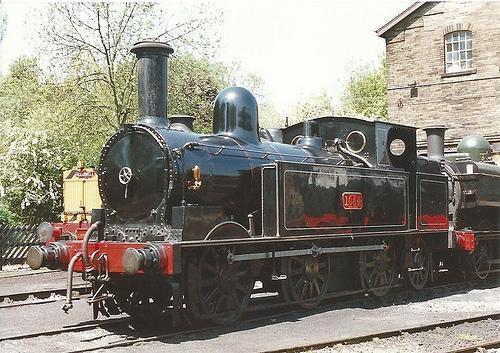How many people are in the picture?
Give a very brief answer. 0. How many trains are in the picture?
Give a very brief answer. 1. 